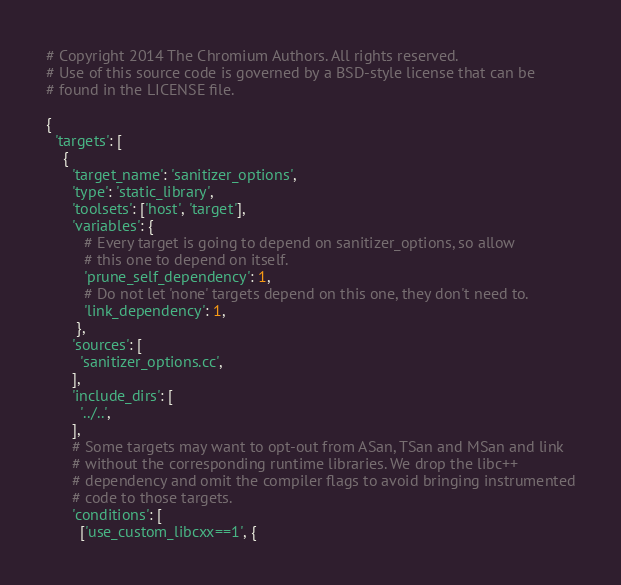Convert code to text. <code><loc_0><loc_0><loc_500><loc_500><_Python_># Copyright 2014 The Chromium Authors. All rights reserved.
# Use of this source code is governed by a BSD-style license that can be
# found in the LICENSE file.

{
  'targets': [
    {
      'target_name': 'sanitizer_options',
      'type': 'static_library',
      'toolsets': ['host', 'target'],
      'variables': {
         # Every target is going to depend on sanitizer_options, so allow
         # this one to depend on itself.
         'prune_self_dependency': 1,
         # Do not let 'none' targets depend on this one, they don't need to.
         'link_dependency': 1,
       },
      'sources': [
        'sanitizer_options.cc',
      ],
      'include_dirs': [
        '../..',
      ],
      # Some targets may want to opt-out from ASan, TSan and MSan and link
      # without the corresponding runtime libraries. We drop the libc++
      # dependency and omit the compiler flags to avoid bringing instrumented
      # code to those targets.
      'conditions': [
        ['use_custom_libcxx==1', {</code> 